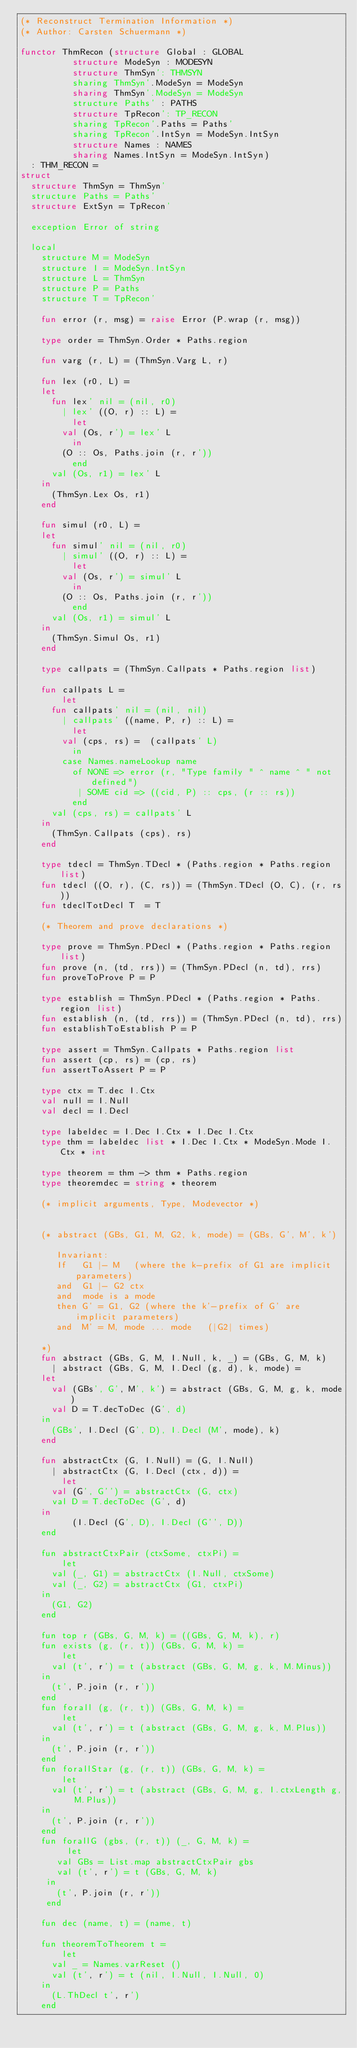Convert code to text. <code><loc_0><loc_0><loc_500><loc_500><_SML_>(* Reconstruct Termination Information *)
(* Author: Carsten Schuermann *)

functor ThmRecon (structure Global : GLOBAL
		  structure ModeSyn : MODESYN
		  structure ThmSyn': THMSYN
		  sharing ThmSyn'.ModeSyn = ModeSyn
		  sharing ThmSyn'.ModeSyn = ModeSyn
		  structure Paths' : PATHS
		  structure TpRecon': TP_RECON
		  sharing TpRecon'.Paths = Paths' 
		  sharing TpRecon'.IntSyn = ModeSyn.IntSyn
		  structure Names : NAMES
		  sharing Names.IntSyn = ModeSyn.IntSyn)
  : THM_RECON =
struct
  structure ThmSyn = ThmSyn'
  structure Paths = Paths'
  structure ExtSyn = TpRecon'

  exception Error of string

  local
    structure M = ModeSyn
    structure I = ModeSyn.IntSyn
    structure L = ThmSyn
    structure P = Paths
    structure T = TpRecon'

    fun error (r, msg) = raise Error (P.wrap (r, msg))

    type order = ThmSyn.Order * Paths.region 

    fun varg (r, L) = (ThmSyn.Varg L, r)

    fun lex (r0, L) = 
	let 
	  fun lex' nil = (nil, r0)
	    | lex' ((O, r) :: L) = 
	      let  
		val (Os, r') = lex' L
	      in
		(O :: Os, Paths.join (r, r'))
	      end
	  val (Os, r1) = lex' L
	in 
	  (ThmSyn.Lex Os, r1)
	end

    fun simul (r0, L) = 
	let 
	  fun simul' nil = (nil, r0)
	    | simul' ((O, r) :: L) = 
	      let  
		val (Os, r') = simul' L
	      in
		(O :: Os, Paths.join (r, r'))
	      end
	  val (Os, r1) = simul' L
	in 
	  (ThmSyn.Simul Os, r1)
	end

    type callpats = (ThmSyn.Callpats * Paths.region list)

    fun callpats L = 
        let 
	  fun callpats' nil = (nil, nil)
	    | callpats' ((name, P, r) :: L) =  
	      let 
		val (cps, rs) =  (callpats' L)
	      in
		case Names.nameLookup name
		  of NONE => error (r, "Type family " ^ name ^ " not defined")
		   | SOME cid => ((cid, P) :: cps, (r :: rs))
	      end
	  val (cps, rs) = callpats' L
	in
	  (ThmSyn.Callpats (cps), rs)
	end

    type tdecl = ThmSyn.TDecl * (Paths.region * Paths.region list) 
    fun tdecl ((O, r), (C, rs)) = (ThmSyn.TDecl (O, C), (r, rs))
    fun tdeclTotDecl T  = T

    (* Theorem and prove declarations *)

    type prove = ThmSyn.PDecl * (Paths.region * Paths.region list)
    fun prove (n, (td, rrs)) = (ThmSyn.PDecl (n, td), rrs)
    fun proveToProve P = P 

    type establish = ThmSyn.PDecl * (Paths.region * Paths.region list)
    fun establish (n, (td, rrs)) = (ThmSyn.PDecl (n, td), rrs)
    fun establishToEstablish P = P 
      
    type assert = ThmSyn.Callpats * Paths.region list
    fun assert (cp, rs) = (cp, rs)
    fun assertToAssert P = P 

    type ctx = T.dec I.Ctx
    val null = I.Null
    val decl = I.Decl

    type labeldec = I.Dec I.Ctx * I.Dec I.Ctx
    type thm = labeldec list * I.Dec I.Ctx * ModeSyn.Mode I.Ctx * int

    type theorem = thm -> thm * Paths.region
    type theoremdec = string * theorem

    (* implicit arguments, Type, Modevector *)


    (* abstract (GBs, G1, M, G2, k, mode) = (GBs, G', M', k')
     
       Invariant:  
       If   G1 |- M   (where the k-prefix of G1 are implicit parameters)
       and  G1 |- G2 ctx
       and  mode is a mode
       then G' = G1, G2 (where the k'-prefix of G' are implicit parameters)
       and  M' = M, mode ... mode   (|G2| times)
       
    *)
    fun abstract (GBs, G, M, I.Null, k, _) = (GBs, G, M, k)
      | abstract (GBs, G, M, I.Decl (g, d), k, mode) =
	let 
	  val (GBs', G', M', k') = abstract (GBs, G, M, g, k, mode)
	  val D = T.decToDec (G', d)
	in
	  (GBs', I.Decl (G', D), I.Decl (M', mode), k)
	end

    fun abstractCtx (G, I.Null) = (G, I.Null)
      | abstractCtx (G, I.Decl (ctx, d)) =
        let
	  val (G', G'') = abstractCtx (G, ctx)
	  val D = T.decToDec (G', d)
	in
          (I.Decl (G', D), I.Decl (G'', D))
	end

    fun abstractCtxPair (ctxSome, ctxPi) =
        let
	  val (_, G1) = abstractCtx (I.Null, ctxSome)
	  val (_, G2) = abstractCtx (G1, ctxPi)
	in
	  (G1, G2)
	end
   
    fun top r (GBs, G, M, k) = ((GBs, G, M, k), r)
    fun exists (g, (r, t)) (GBs, G, M, k) = 
        let 
	  val (t', r') = t (abstract (GBs, G, M, g, k, M.Minus))
	in
	  (t', P.join (r, r'))
	end
    fun forall (g, (r, t)) (GBs, G, M, k) = 
        let 
	  val (t', r') = t (abstract (GBs, G, M, g, k, M.Plus))
	in
	  (t', P.join (r, r'))
	end
    fun forallStar (g, (r, t)) (GBs, G, M, k) = 
        let
	  val (t', r') = t (abstract (GBs, G, M, g, I.ctxLength g, M.Plus))
	in
	  (t', P.join (r, r'))
	end
    fun forallG (gbs, (r, t)) (_, G, M, k) =
         let
	   val GBs = List.map abstractCtxPair gbs
	   val (t', r') = t (GBs, G, M, k)
	 in
	   (t', P.join (r, r'))
	 end

    fun dec (name, t) = (name, t)

    fun theoremToTheorem t = 
        let
	  val _ = Names.varReset ()
	  val (t', r') = t (nil, I.Null, I.Null, 0)
	in
	  (L.ThDecl t', r')
	end
</code> 